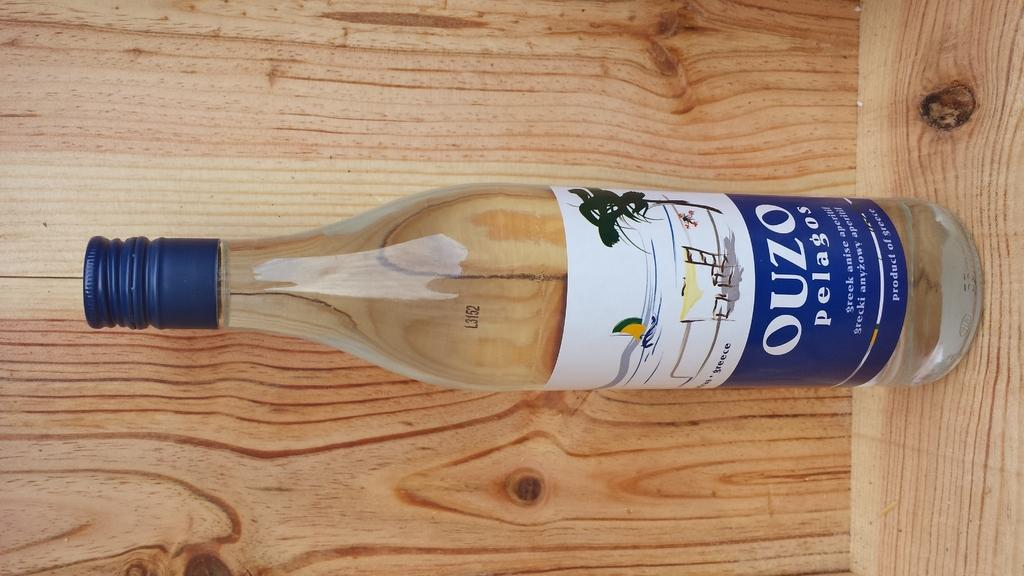What object is featured in the image? There is a bottle in the image. How is the bottle being emphasized in the image? The bottle is highlighted in the image. What color is the cap of the bottle? The bottle has a blue cap. Can you see any fangs on the bottle in the image? There are no fangs present on the bottle in the image. What type of stream is flowing near the bottle in the image? There is no stream present in the image; it only features a bottle with a blue cap. 